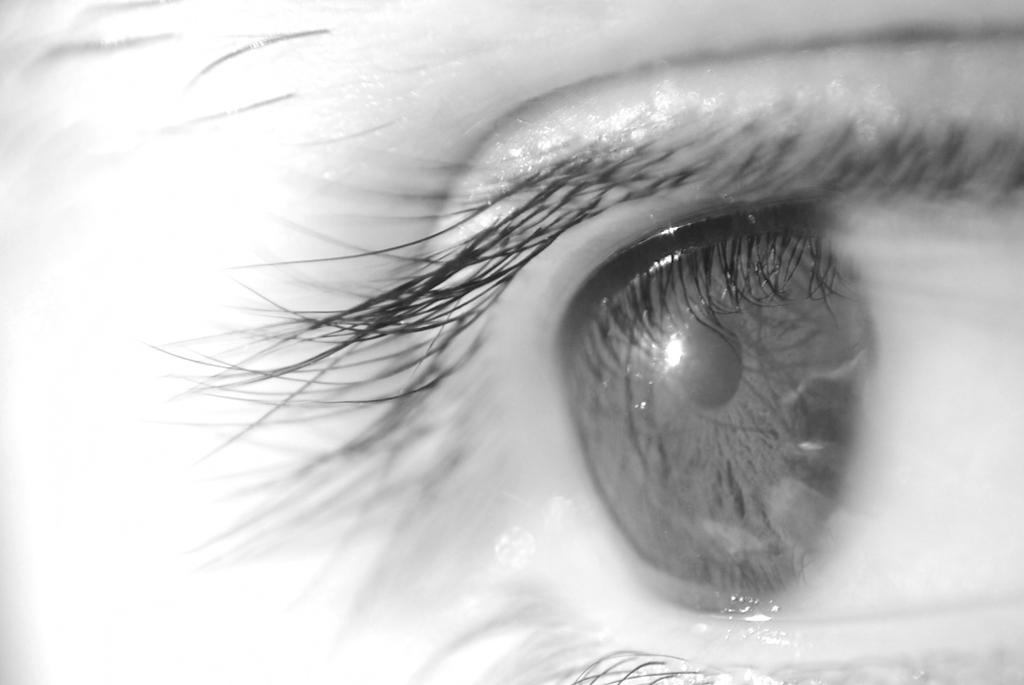What is the color scheme of the image? The image is black and white. What can be seen in the image? There is an eye of a person in the image. What type of agreement is being signed in the image? There is no agreement or signing activity present in the image; it only features an eye of a person. Can you tell me how many lamps are visible in the image? There are no lamps present in the image; it only features an eye of a person. 